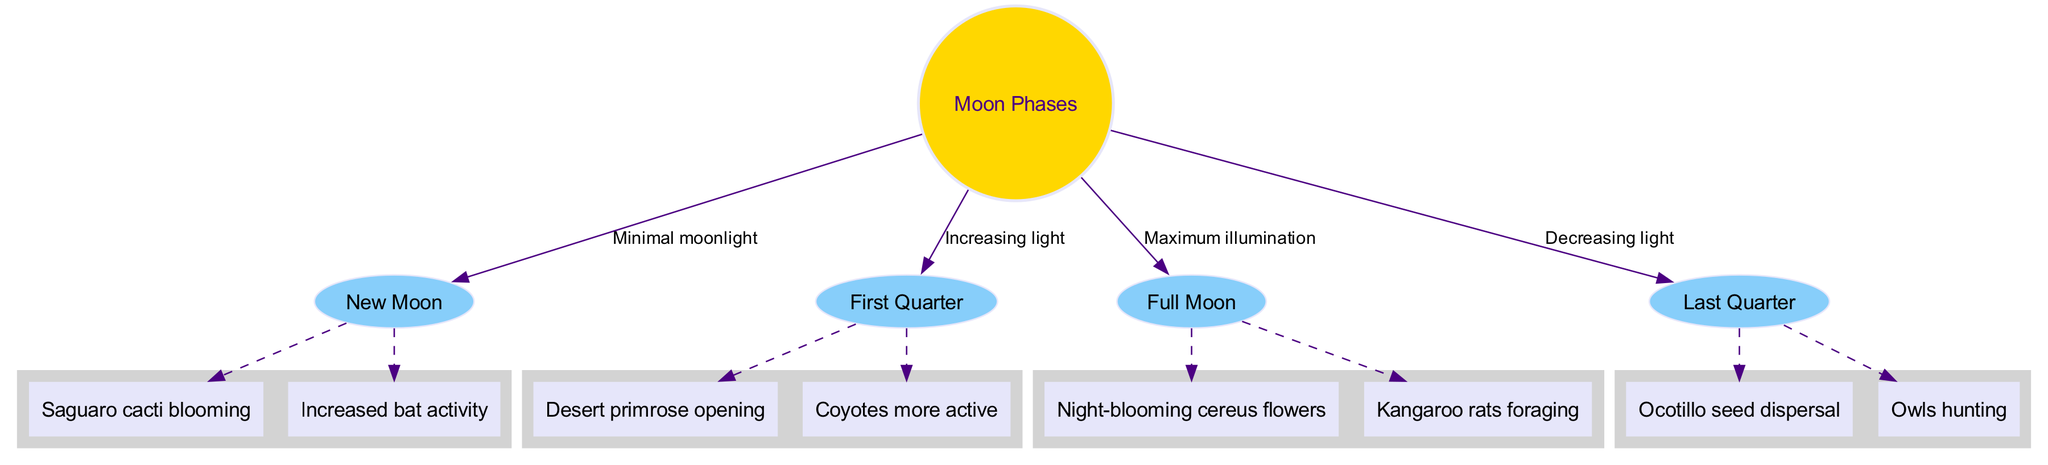What are the moon phases listed in the diagram? The diagram lists four main moon phases: New Moon, First Quarter, Full Moon, and Last Quarter.
Answer: New Moon, First Quarter, Full Moon, Last Quarter Which moon phase has maximum illumination? According to the diagram, the Full Moon represents the phase with maximum illumination.
Answer: Full Moon How many sub-nodes are associated with the New Moon phase? The New Moon phase has two associated sub-nodes: Saguaro cacti blooming and Increased bat activity. Therefore, the count is two.
Answer: 2 What activity is increased during the First Quarter? The sub-node associated with increased activity during the First Quarter is Coyotes more active.
Answer: Coyotes more active During which moon phase do owls primarily hunt? The diagram indicates that owls mostly hunt during the Last Quarter phase.
Answer: Last Quarter What is the light condition during a New Moon? The diagram states that the New Moon is characterized by minimal moonlight.
Answer: Minimal moonlight How does the amount of moonlight change from the New Moon to the Full Moon? The diagram shows that the light increases from Minimal moonlight during the New Moon to Maximum illumination at the Full Moon.
Answer: Increases Which nocturnal wildlife forages during the Full Moon phase? The diagram specifically notes Kangaroo rats foraging during the Full Moon phase.
Answer: Kangaroo rats foraging What does the Last Quarter phase contribute in terms of plant activity? The diagram indicates that the Last Quarter phase is associated with Ocotillo seed dispersal.
Answer: Ocotillo seed dispersal 